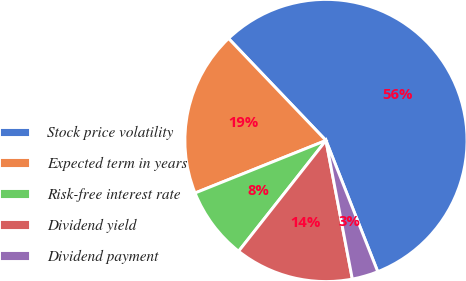Convert chart to OTSL. <chart><loc_0><loc_0><loc_500><loc_500><pie_chart><fcel>Stock price volatility<fcel>Expected term in years<fcel>Risk-free interest rate<fcel>Dividend yield<fcel>Dividend payment<nl><fcel>56.15%<fcel>18.94%<fcel>8.3%<fcel>13.62%<fcel>2.99%<nl></chart> 